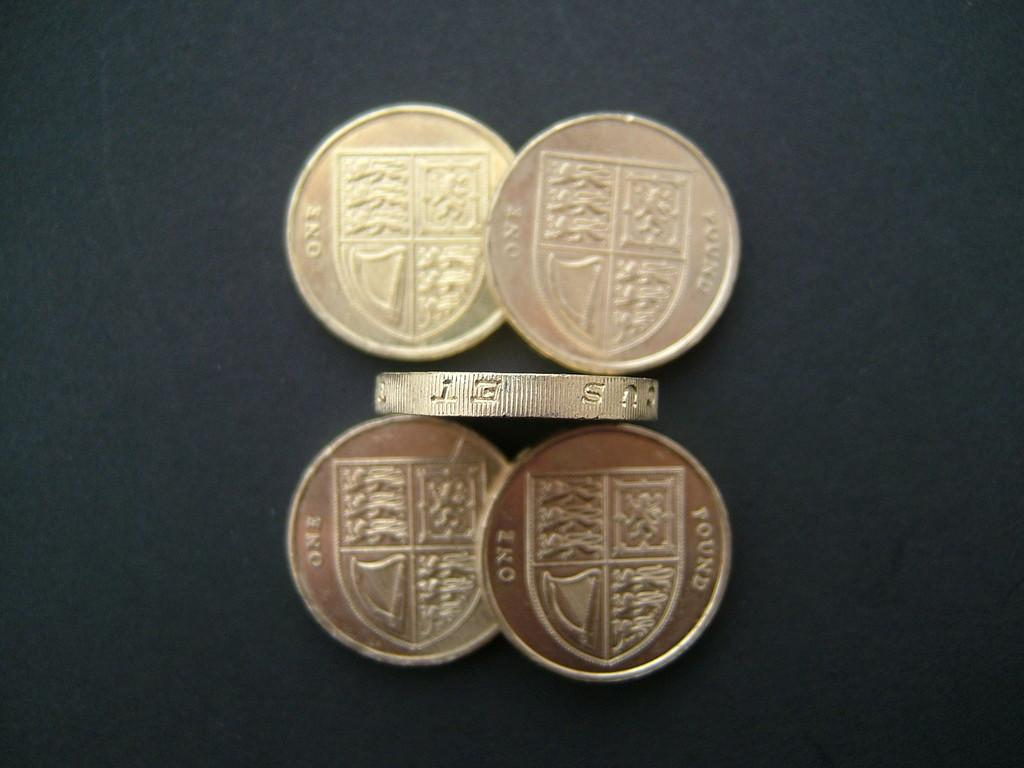Provide a one-sentence caption for the provided image. Four coins engraved with one found on the back of them. 